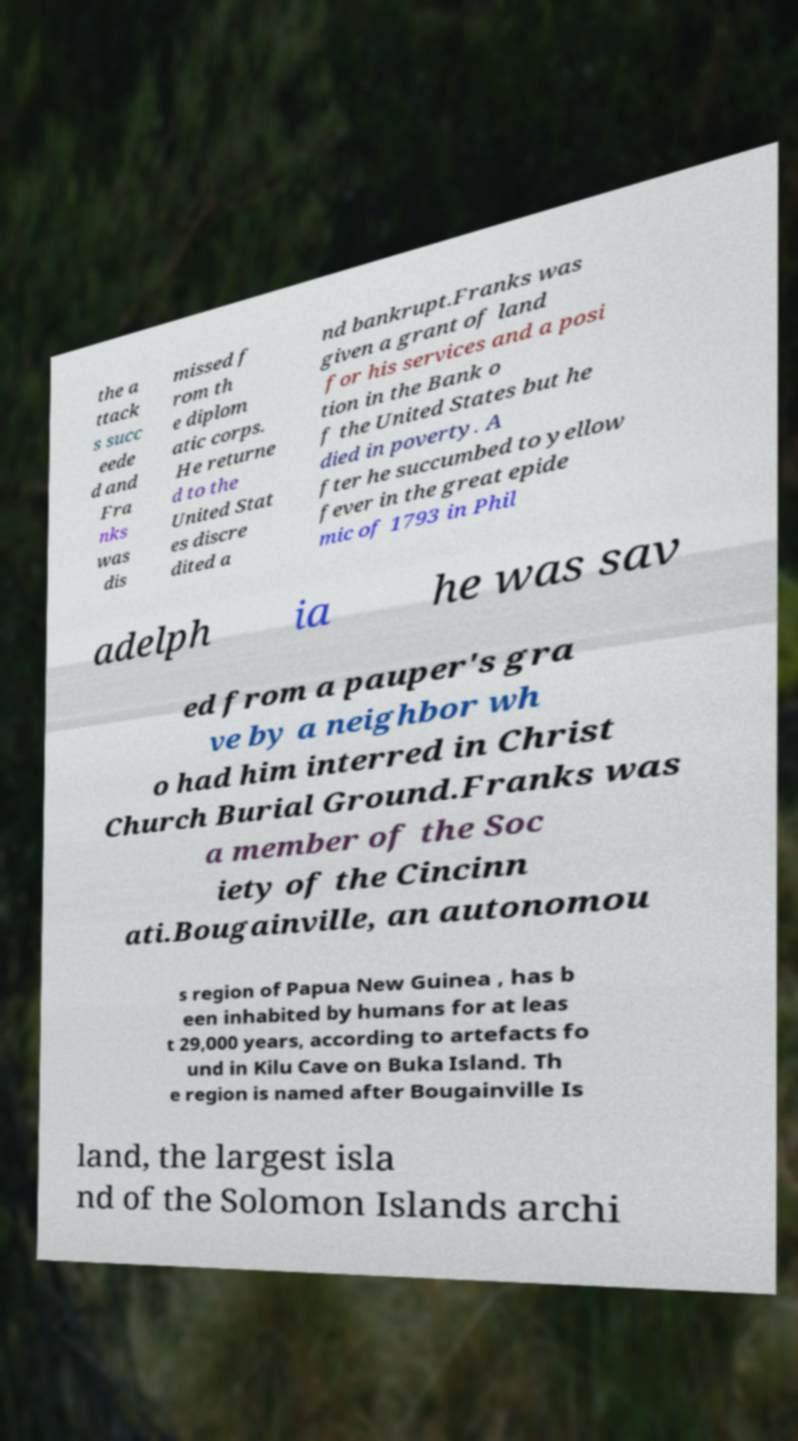Could you assist in decoding the text presented in this image and type it out clearly? the a ttack s succ eede d and Fra nks was dis missed f rom th e diplom atic corps. He returne d to the United Stat es discre dited a nd bankrupt.Franks was given a grant of land for his services and a posi tion in the Bank o f the United States but he died in poverty. A fter he succumbed to yellow fever in the great epide mic of 1793 in Phil adelph ia he was sav ed from a pauper's gra ve by a neighbor wh o had him interred in Christ Church Burial Ground.Franks was a member of the Soc iety of the Cincinn ati.Bougainville, an autonomou s region of Papua New Guinea , has b een inhabited by humans for at leas t 29,000 years, according to artefacts fo und in Kilu Cave on Buka Island. Th e region is named after Bougainville Is land, the largest isla nd of the Solomon Islands archi 